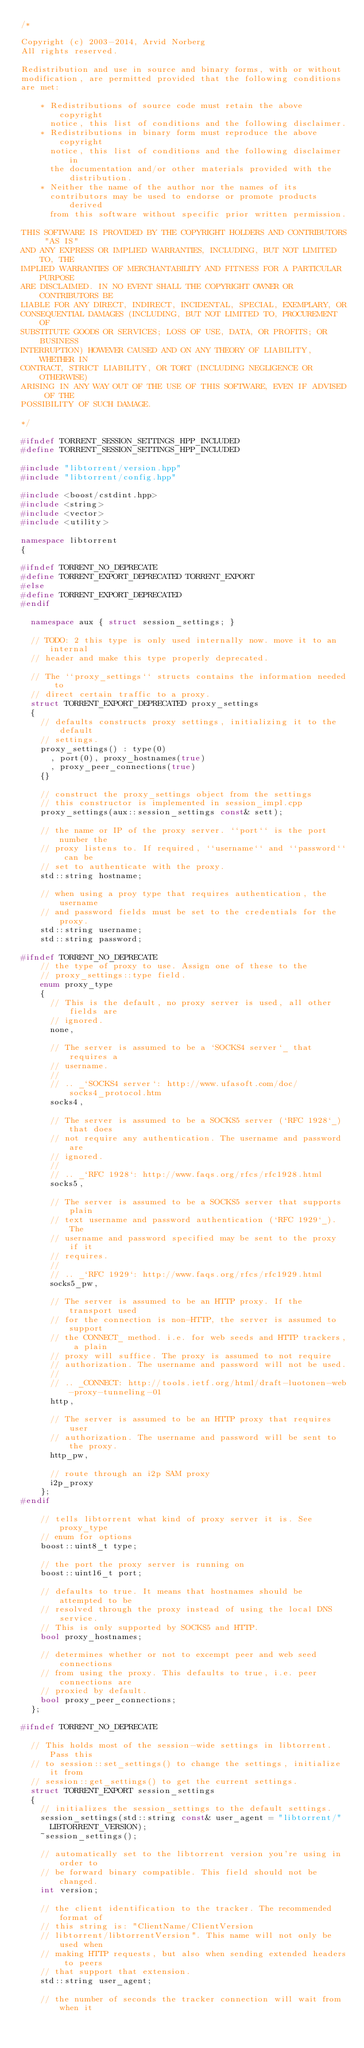Convert code to text. <code><loc_0><loc_0><loc_500><loc_500><_C++_>/*

Copyright (c) 2003-2014, Arvid Norberg
All rights reserved.

Redistribution and use in source and binary forms, with or without
modification, are permitted provided that the following conditions
are met:

    * Redistributions of source code must retain the above copyright
      notice, this list of conditions and the following disclaimer.
    * Redistributions in binary form must reproduce the above copyright
      notice, this list of conditions and the following disclaimer in
      the documentation and/or other materials provided with the distribution.
    * Neither the name of the author nor the names of its
      contributors may be used to endorse or promote products derived
      from this software without specific prior written permission.

THIS SOFTWARE IS PROVIDED BY THE COPYRIGHT HOLDERS AND CONTRIBUTORS "AS IS"
AND ANY EXPRESS OR IMPLIED WARRANTIES, INCLUDING, BUT NOT LIMITED TO, THE
IMPLIED WARRANTIES OF MERCHANTABILITY AND FITNESS FOR A PARTICULAR PURPOSE
ARE DISCLAIMED. IN NO EVENT SHALL THE COPYRIGHT OWNER OR CONTRIBUTORS BE
LIABLE FOR ANY DIRECT, INDIRECT, INCIDENTAL, SPECIAL, EXEMPLARY, OR
CONSEQUENTIAL DAMAGES (INCLUDING, BUT NOT LIMITED TO, PROCUREMENT OF
SUBSTITUTE GOODS OR SERVICES; LOSS OF USE, DATA, OR PROFITS; OR BUSINESS
INTERRUPTION) HOWEVER CAUSED AND ON ANY THEORY OF LIABILITY, WHETHER IN
CONTRACT, STRICT LIABILITY, OR TORT (INCLUDING NEGLIGENCE OR OTHERWISE)
ARISING IN ANY WAY OUT OF THE USE OF THIS SOFTWARE, EVEN IF ADVISED OF THE
POSSIBILITY OF SUCH DAMAGE.

*/

#ifndef TORRENT_SESSION_SETTINGS_HPP_INCLUDED
#define TORRENT_SESSION_SETTINGS_HPP_INCLUDED

#include "libtorrent/version.hpp"
#include "libtorrent/config.hpp"

#include <boost/cstdint.hpp>
#include <string>
#include <vector>
#include <utility>

namespace libtorrent
{

#ifndef TORRENT_NO_DEPRECATE
#define TORRENT_EXPORT_DEPRECATED TORRENT_EXPORT
#else
#define TORRENT_EXPORT_DEPRECATED
#endif

	namespace aux { struct session_settings; }

	// TODO: 2 this type is only used internally now. move it to an internal
	// header and make this type properly deprecated.

	// The ``proxy_settings`` structs contains the information needed to
	// direct certain traffic to a proxy.
	struct TORRENT_EXPORT_DEPRECATED proxy_settings
	{
		// defaults constructs proxy settings, initializing it to the default
		// settings.
		proxy_settings() : type(0)
			, port(0), proxy_hostnames(true)
			, proxy_peer_connections(true)
		{}

		// construct the proxy_settings object from the settings
		// this constructor is implemented in session_impl.cpp
		proxy_settings(aux::session_settings const& sett);

		// the name or IP of the proxy server. ``port`` is the port number the
		// proxy listens to. If required, ``username`` and ``password`` can be
		// set to authenticate with the proxy.
		std::string hostname;

		// when using a proy type that requires authentication, the username
		// and password fields must be set to the credentials for the proxy.
		std::string username;
		std::string password;

#ifndef TORRENT_NO_DEPRECATE
		// the type of proxy to use. Assign one of these to the
		// proxy_settings::type field.
		enum proxy_type
		{
			// This is the default, no proxy server is used, all other fields are
			// ignored.
			none,

			// The server is assumed to be a `SOCKS4 server`_ that requires a
			// username.
			//
			// .. _`SOCKS4 server`: http://www.ufasoft.com/doc/socks4_protocol.htm
			socks4,

			// The server is assumed to be a SOCKS5 server (`RFC 1928`_) that does
			// not require any authentication. The username and password are
			// ignored.
			//
			// .. _`RFC 1928`: http://www.faqs.org/rfcs/rfc1928.html
			socks5,

			// The server is assumed to be a SOCKS5 server that supports plain
			// text username and password authentication (`RFC 1929`_). The
			// username and password specified may be sent to the proxy if it
			// requires.
			//
			// .. _`RFC 1929`: http://www.faqs.org/rfcs/rfc1929.html
			socks5_pw,

			// The server is assumed to be an HTTP proxy. If the transport used
			// for the connection is non-HTTP, the server is assumed to support
			// the CONNECT_ method. i.e. for web seeds and HTTP trackers, a plain
			// proxy will suffice. The proxy is assumed to not require
			// authorization. The username and password will not be used.
			//
			// .. _CONNECT: http://tools.ietf.org/html/draft-luotonen-web-proxy-tunneling-01
			http,

			// The server is assumed to be an HTTP proxy that requires user
			// authorization. The username and password will be sent to the proxy.
			http_pw,

			// route through an i2p SAM proxy
			i2p_proxy
		};
#endif
		
		// tells libtorrent what kind of proxy server it is. See proxy_type
		// enum for options
		boost::uint8_t type;

		// the port the proxy server is running on
		boost::uint16_t port;

		// defaults to true. It means that hostnames should be attempted to be
		// resolved through the proxy instead of using the local DNS service.
		// This is only supported by SOCKS5 and HTTP.
		bool proxy_hostnames;

		// determines whether or not to excempt peer and web seed connections
		// from using the proxy. This defaults to true, i.e. peer connections are
		// proxied by default.
		bool proxy_peer_connections;
	};

#ifndef TORRENT_NO_DEPRECATE

	// This holds most of the session-wide settings in libtorrent. Pass this
	// to session::set_settings() to change the settings, initialize it from
	// session::get_settings() to get the current settings.
	struct TORRENT_EXPORT session_settings
	{
		// initializes the session_settings to the default settings.
		session_settings(std::string const& user_agent = "libtorrent/"
			LIBTORRENT_VERSION);
		~session_settings();

		// automatically set to the libtorrent version you're using in order to
		// be forward binary compatible. This field should not be changed.
		int version;

		// the client identification to the tracker. The recommended format of
		// this string is: "ClientName/ClientVersion
		// libtorrent/libtorrentVersion". This name will not only be used when
		// making HTTP requests, but also when sending extended headers to peers
		// that support that extension.
		std::string user_agent;

		// the number of seconds the tracker connection will wait from when it</code> 